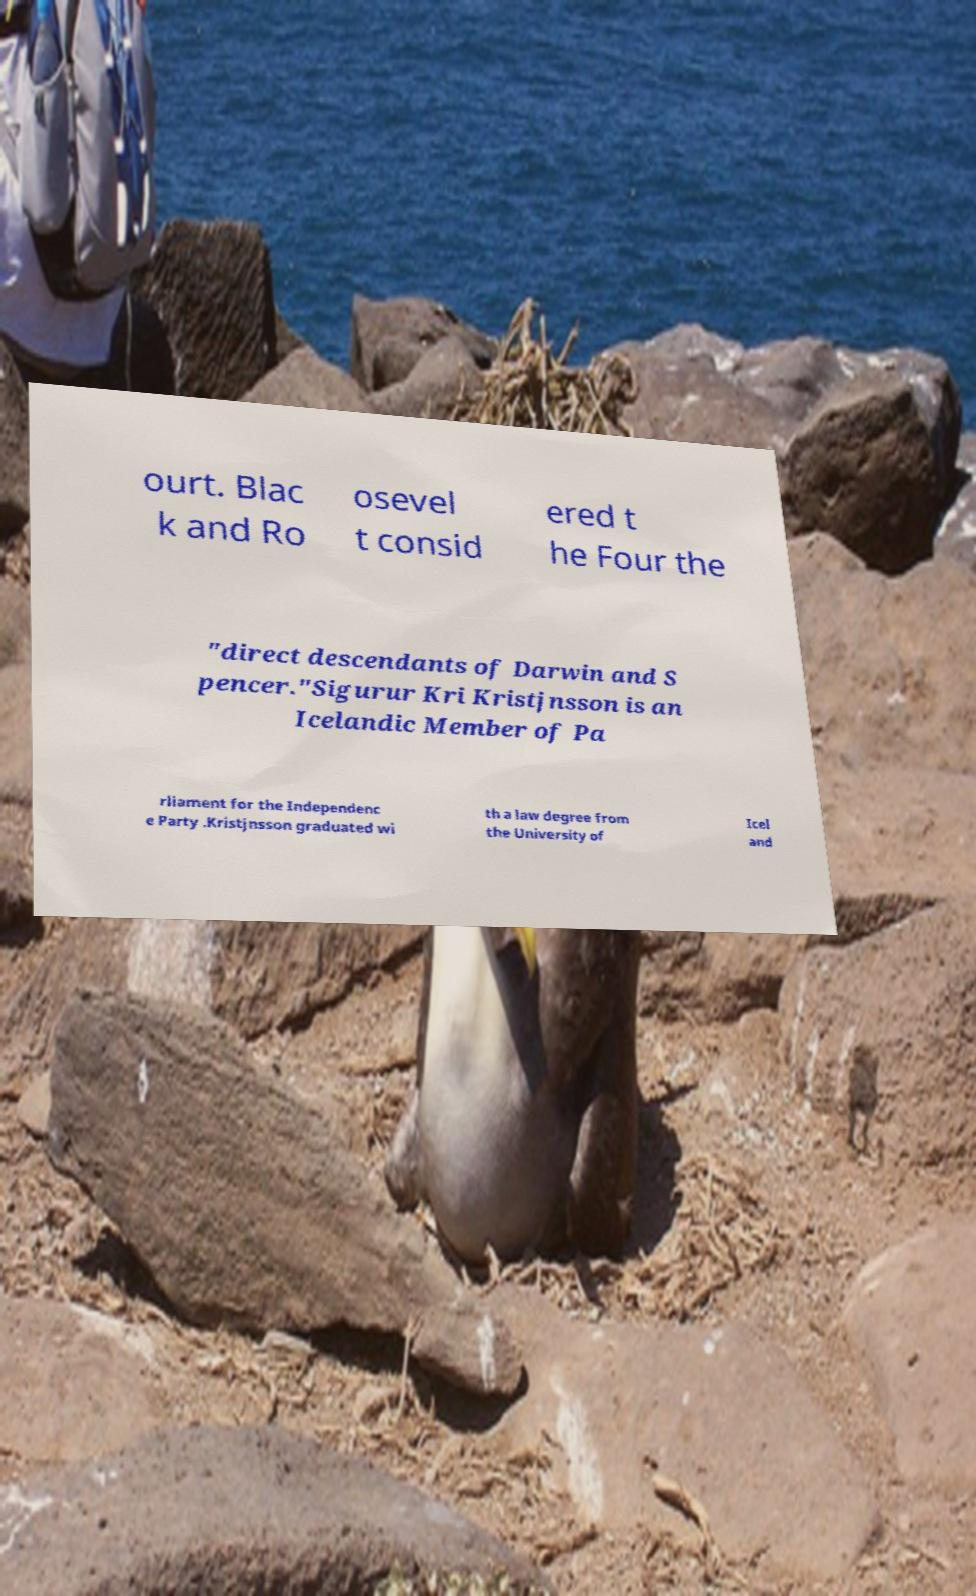I need the written content from this picture converted into text. Can you do that? ourt. Blac k and Ro osevel t consid ered t he Four the "direct descendants of Darwin and S pencer."Sigurur Kri Kristjnsson is an Icelandic Member of Pa rliament for the Independenc e Party .Kristjnsson graduated wi th a law degree from the University of Icel and 